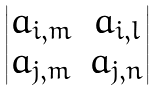Convert formula to latex. <formula><loc_0><loc_0><loc_500><loc_500>\begin{vmatrix} a _ { i , m } & a _ { i , l } \\ a _ { j , m } & a _ { j , n } \\ \end{vmatrix}</formula> 